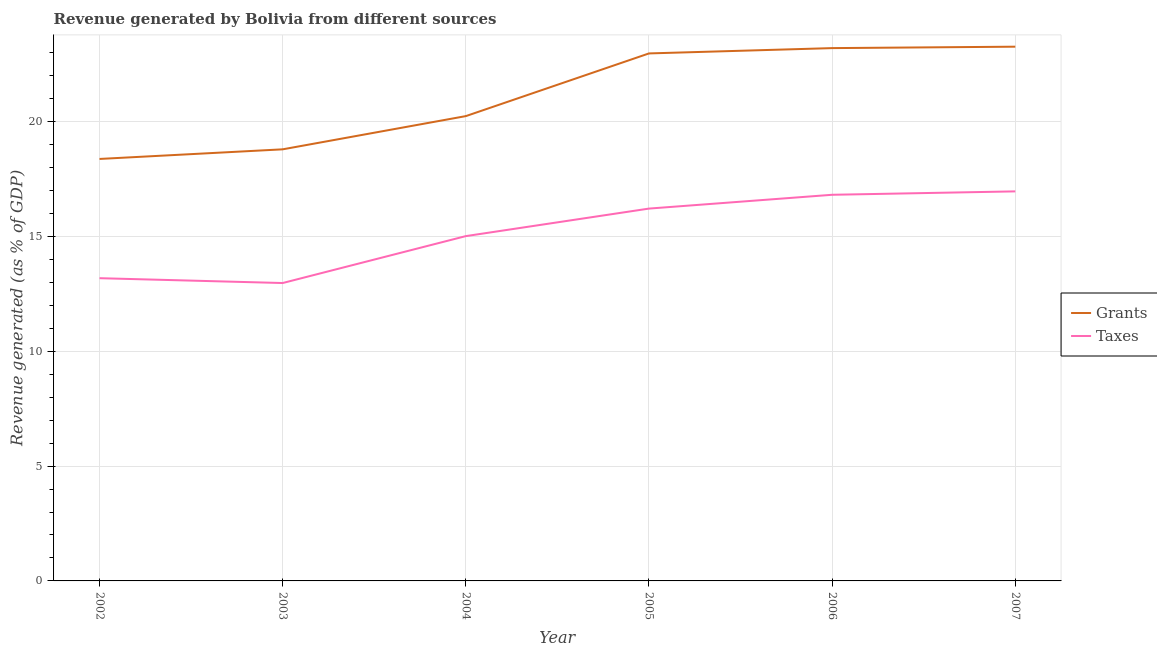How many different coloured lines are there?
Ensure brevity in your answer.  2. What is the revenue generated by grants in 2003?
Ensure brevity in your answer.  18.8. Across all years, what is the maximum revenue generated by taxes?
Provide a succinct answer. 16.96. Across all years, what is the minimum revenue generated by taxes?
Offer a terse response. 12.97. In which year was the revenue generated by taxes maximum?
Provide a short and direct response. 2007. In which year was the revenue generated by grants minimum?
Your response must be concise. 2002. What is the total revenue generated by taxes in the graph?
Make the answer very short. 91.17. What is the difference between the revenue generated by grants in 2005 and that in 2007?
Give a very brief answer. -0.29. What is the difference between the revenue generated by taxes in 2002 and the revenue generated by grants in 2005?
Keep it short and to the point. -9.79. What is the average revenue generated by taxes per year?
Ensure brevity in your answer.  15.19. In the year 2002, what is the difference between the revenue generated by taxes and revenue generated by grants?
Ensure brevity in your answer.  -5.19. In how many years, is the revenue generated by grants greater than 15 %?
Offer a very short reply. 6. What is the ratio of the revenue generated by taxes in 2005 to that in 2006?
Provide a succinct answer. 0.96. Is the revenue generated by taxes in 2004 less than that in 2005?
Give a very brief answer. Yes. Is the difference between the revenue generated by grants in 2002 and 2005 greater than the difference between the revenue generated by taxes in 2002 and 2005?
Provide a short and direct response. No. What is the difference between the highest and the second highest revenue generated by taxes?
Your answer should be compact. 0.15. What is the difference between the highest and the lowest revenue generated by taxes?
Keep it short and to the point. 3.99. Is the sum of the revenue generated by grants in 2002 and 2005 greater than the maximum revenue generated by taxes across all years?
Your answer should be very brief. Yes. Does the revenue generated by taxes monotonically increase over the years?
Provide a succinct answer. No. How many lines are there?
Offer a terse response. 2. How many years are there in the graph?
Offer a very short reply. 6. Are the values on the major ticks of Y-axis written in scientific E-notation?
Your answer should be very brief. No. Does the graph contain any zero values?
Provide a succinct answer. No. How many legend labels are there?
Ensure brevity in your answer.  2. What is the title of the graph?
Provide a short and direct response. Revenue generated by Bolivia from different sources. What is the label or title of the Y-axis?
Your answer should be very brief. Revenue generated (as % of GDP). What is the Revenue generated (as % of GDP) in Grants in 2002?
Your response must be concise. 18.38. What is the Revenue generated (as % of GDP) of Taxes in 2002?
Give a very brief answer. 13.18. What is the Revenue generated (as % of GDP) of Grants in 2003?
Offer a terse response. 18.8. What is the Revenue generated (as % of GDP) in Taxes in 2003?
Offer a terse response. 12.97. What is the Revenue generated (as % of GDP) in Grants in 2004?
Your response must be concise. 20.24. What is the Revenue generated (as % of GDP) of Taxes in 2004?
Ensure brevity in your answer.  15.02. What is the Revenue generated (as % of GDP) of Grants in 2005?
Offer a very short reply. 22.97. What is the Revenue generated (as % of GDP) of Taxes in 2005?
Offer a very short reply. 16.22. What is the Revenue generated (as % of GDP) in Grants in 2006?
Provide a short and direct response. 23.2. What is the Revenue generated (as % of GDP) in Taxes in 2006?
Offer a very short reply. 16.82. What is the Revenue generated (as % of GDP) of Grants in 2007?
Your answer should be compact. 23.27. What is the Revenue generated (as % of GDP) in Taxes in 2007?
Your answer should be compact. 16.96. Across all years, what is the maximum Revenue generated (as % of GDP) in Grants?
Your answer should be compact. 23.27. Across all years, what is the maximum Revenue generated (as % of GDP) in Taxes?
Give a very brief answer. 16.96. Across all years, what is the minimum Revenue generated (as % of GDP) in Grants?
Keep it short and to the point. 18.38. Across all years, what is the minimum Revenue generated (as % of GDP) of Taxes?
Make the answer very short. 12.97. What is the total Revenue generated (as % of GDP) of Grants in the graph?
Give a very brief answer. 126.86. What is the total Revenue generated (as % of GDP) in Taxes in the graph?
Keep it short and to the point. 91.17. What is the difference between the Revenue generated (as % of GDP) in Grants in 2002 and that in 2003?
Offer a very short reply. -0.42. What is the difference between the Revenue generated (as % of GDP) in Taxes in 2002 and that in 2003?
Ensure brevity in your answer.  0.21. What is the difference between the Revenue generated (as % of GDP) in Grants in 2002 and that in 2004?
Provide a short and direct response. -1.87. What is the difference between the Revenue generated (as % of GDP) of Taxes in 2002 and that in 2004?
Offer a very short reply. -1.83. What is the difference between the Revenue generated (as % of GDP) of Grants in 2002 and that in 2005?
Make the answer very short. -4.6. What is the difference between the Revenue generated (as % of GDP) in Taxes in 2002 and that in 2005?
Provide a succinct answer. -3.03. What is the difference between the Revenue generated (as % of GDP) in Grants in 2002 and that in 2006?
Your response must be concise. -4.83. What is the difference between the Revenue generated (as % of GDP) of Taxes in 2002 and that in 2006?
Make the answer very short. -3.63. What is the difference between the Revenue generated (as % of GDP) in Grants in 2002 and that in 2007?
Ensure brevity in your answer.  -4.89. What is the difference between the Revenue generated (as % of GDP) in Taxes in 2002 and that in 2007?
Your answer should be compact. -3.78. What is the difference between the Revenue generated (as % of GDP) of Grants in 2003 and that in 2004?
Your answer should be compact. -1.45. What is the difference between the Revenue generated (as % of GDP) of Taxes in 2003 and that in 2004?
Give a very brief answer. -2.04. What is the difference between the Revenue generated (as % of GDP) in Grants in 2003 and that in 2005?
Offer a very short reply. -4.18. What is the difference between the Revenue generated (as % of GDP) of Taxes in 2003 and that in 2005?
Your answer should be very brief. -3.24. What is the difference between the Revenue generated (as % of GDP) of Grants in 2003 and that in 2006?
Ensure brevity in your answer.  -4.41. What is the difference between the Revenue generated (as % of GDP) of Taxes in 2003 and that in 2006?
Ensure brevity in your answer.  -3.84. What is the difference between the Revenue generated (as % of GDP) in Grants in 2003 and that in 2007?
Offer a terse response. -4.47. What is the difference between the Revenue generated (as % of GDP) of Taxes in 2003 and that in 2007?
Your response must be concise. -3.99. What is the difference between the Revenue generated (as % of GDP) of Grants in 2004 and that in 2005?
Your answer should be compact. -2.73. What is the difference between the Revenue generated (as % of GDP) of Taxes in 2004 and that in 2005?
Your answer should be compact. -1.2. What is the difference between the Revenue generated (as % of GDP) in Grants in 2004 and that in 2006?
Make the answer very short. -2.96. What is the difference between the Revenue generated (as % of GDP) in Taxes in 2004 and that in 2006?
Offer a terse response. -1.8. What is the difference between the Revenue generated (as % of GDP) of Grants in 2004 and that in 2007?
Your response must be concise. -3.02. What is the difference between the Revenue generated (as % of GDP) in Taxes in 2004 and that in 2007?
Provide a short and direct response. -1.95. What is the difference between the Revenue generated (as % of GDP) of Grants in 2005 and that in 2006?
Your response must be concise. -0.23. What is the difference between the Revenue generated (as % of GDP) of Taxes in 2005 and that in 2006?
Offer a very short reply. -0.6. What is the difference between the Revenue generated (as % of GDP) of Grants in 2005 and that in 2007?
Offer a very short reply. -0.29. What is the difference between the Revenue generated (as % of GDP) of Taxes in 2005 and that in 2007?
Give a very brief answer. -0.75. What is the difference between the Revenue generated (as % of GDP) of Grants in 2006 and that in 2007?
Provide a short and direct response. -0.06. What is the difference between the Revenue generated (as % of GDP) of Taxes in 2006 and that in 2007?
Offer a terse response. -0.15. What is the difference between the Revenue generated (as % of GDP) in Grants in 2002 and the Revenue generated (as % of GDP) in Taxes in 2003?
Your answer should be very brief. 5.4. What is the difference between the Revenue generated (as % of GDP) in Grants in 2002 and the Revenue generated (as % of GDP) in Taxes in 2004?
Your answer should be very brief. 3.36. What is the difference between the Revenue generated (as % of GDP) of Grants in 2002 and the Revenue generated (as % of GDP) of Taxes in 2005?
Your answer should be very brief. 2.16. What is the difference between the Revenue generated (as % of GDP) in Grants in 2002 and the Revenue generated (as % of GDP) in Taxes in 2006?
Your answer should be compact. 1.56. What is the difference between the Revenue generated (as % of GDP) of Grants in 2002 and the Revenue generated (as % of GDP) of Taxes in 2007?
Your answer should be compact. 1.41. What is the difference between the Revenue generated (as % of GDP) of Grants in 2003 and the Revenue generated (as % of GDP) of Taxes in 2004?
Make the answer very short. 3.78. What is the difference between the Revenue generated (as % of GDP) of Grants in 2003 and the Revenue generated (as % of GDP) of Taxes in 2005?
Your answer should be very brief. 2.58. What is the difference between the Revenue generated (as % of GDP) in Grants in 2003 and the Revenue generated (as % of GDP) in Taxes in 2006?
Give a very brief answer. 1.98. What is the difference between the Revenue generated (as % of GDP) of Grants in 2003 and the Revenue generated (as % of GDP) of Taxes in 2007?
Ensure brevity in your answer.  1.83. What is the difference between the Revenue generated (as % of GDP) in Grants in 2004 and the Revenue generated (as % of GDP) in Taxes in 2005?
Your answer should be very brief. 4.03. What is the difference between the Revenue generated (as % of GDP) in Grants in 2004 and the Revenue generated (as % of GDP) in Taxes in 2006?
Keep it short and to the point. 3.43. What is the difference between the Revenue generated (as % of GDP) in Grants in 2004 and the Revenue generated (as % of GDP) in Taxes in 2007?
Offer a terse response. 3.28. What is the difference between the Revenue generated (as % of GDP) of Grants in 2005 and the Revenue generated (as % of GDP) of Taxes in 2006?
Provide a short and direct response. 6.16. What is the difference between the Revenue generated (as % of GDP) of Grants in 2005 and the Revenue generated (as % of GDP) of Taxes in 2007?
Offer a very short reply. 6.01. What is the difference between the Revenue generated (as % of GDP) of Grants in 2006 and the Revenue generated (as % of GDP) of Taxes in 2007?
Provide a short and direct response. 6.24. What is the average Revenue generated (as % of GDP) in Grants per year?
Keep it short and to the point. 21.14. What is the average Revenue generated (as % of GDP) in Taxes per year?
Keep it short and to the point. 15.19. In the year 2002, what is the difference between the Revenue generated (as % of GDP) of Grants and Revenue generated (as % of GDP) of Taxes?
Your answer should be compact. 5.19. In the year 2003, what is the difference between the Revenue generated (as % of GDP) in Grants and Revenue generated (as % of GDP) in Taxes?
Your answer should be very brief. 5.82. In the year 2004, what is the difference between the Revenue generated (as % of GDP) in Grants and Revenue generated (as % of GDP) in Taxes?
Your answer should be compact. 5.23. In the year 2005, what is the difference between the Revenue generated (as % of GDP) of Grants and Revenue generated (as % of GDP) of Taxes?
Provide a short and direct response. 6.76. In the year 2006, what is the difference between the Revenue generated (as % of GDP) of Grants and Revenue generated (as % of GDP) of Taxes?
Provide a short and direct response. 6.39. In the year 2007, what is the difference between the Revenue generated (as % of GDP) in Grants and Revenue generated (as % of GDP) in Taxes?
Make the answer very short. 6.3. What is the ratio of the Revenue generated (as % of GDP) of Grants in 2002 to that in 2003?
Make the answer very short. 0.98. What is the ratio of the Revenue generated (as % of GDP) in Taxes in 2002 to that in 2003?
Your answer should be compact. 1.02. What is the ratio of the Revenue generated (as % of GDP) of Grants in 2002 to that in 2004?
Your answer should be compact. 0.91. What is the ratio of the Revenue generated (as % of GDP) in Taxes in 2002 to that in 2004?
Your answer should be very brief. 0.88. What is the ratio of the Revenue generated (as % of GDP) of Taxes in 2002 to that in 2005?
Keep it short and to the point. 0.81. What is the ratio of the Revenue generated (as % of GDP) in Grants in 2002 to that in 2006?
Your answer should be very brief. 0.79. What is the ratio of the Revenue generated (as % of GDP) of Taxes in 2002 to that in 2006?
Your answer should be very brief. 0.78. What is the ratio of the Revenue generated (as % of GDP) in Grants in 2002 to that in 2007?
Provide a short and direct response. 0.79. What is the ratio of the Revenue generated (as % of GDP) of Taxes in 2002 to that in 2007?
Provide a succinct answer. 0.78. What is the ratio of the Revenue generated (as % of GDP) of Grants in 2003 to that in 2004?
Give a very brief answer. 0.93. What is the ratio of the Revenue generated (as % of GDP) of Taxes in 2003 to that in 2004?
Ensure brevity in your answer.  0.86. What is the ratio of the Revenue generated (as % of GDP) in Grants in 2003 to that in 2005?
Keep it short and to the point. 0.82. What is the ratio of the Revenue generated (as % of GDP) of Taxes in 2003 to that in 2005?
Keep it short and to the point. 0.8. What is the ratio of the Revenue generated (as % of GDP) in Grants in 2003 to that in 2006?
Ensure brevity in your answer.  0.81. What is the ratio of the Revenue generated (as % of GDP) of Taxes in 2003 to that in 2006?
Keep it short and to the point. 0.77. What is the ratio of the Revenue generated (as % of GDP) in Grants in 2003 to that in 2007?
Your response must be concise. 0.81. What is the ratio of the Revenue generated (as % of GDP) of Taxes in 2003 to that in 2007?
Provide a succinct answer. 0.76. What is the ratio of the Revenue generated (as % of GDP) in Grants in 2004 to that in 2005?
Keep it short and to the point. 0.88. What is the ratio of the Revenue generated (as % of GDP) of Taxes in 2004 to that in 2005?
Provide a short and direct response. 0.93. What is the ratio of the Revenue generated (as % of GDP) of Grants in 2004 to that in 2006?
Offer a very short reply. 0.87. What is the ratio of the Revenue generated (as % of GDP) of Taxes in 2004 to that in 2006?
Ensure brevity in your answer.  0.89. What is the ratio of the Revenue generated (as % of GDP) of Grants in 2004 to that in 2007?
Keep it short and to the point. 0.87. What is the ratio of the Revenue generated (as % of GDP) in Taxes in 2004 to that in 2007?
Provide a succinct answer. 0.89. What is the ratio of the Revenue generated (as % of GDP) of Grants in 2005 to that in 2006?
Keep it short and to the point. 0.99. What is the ratio of the Revenue generated (as % of GDP) of Grants in 2005 to that in 2007?
Your response must be concise. 0.99. What is the ratio of the Revenue generated (as % of GDP) in Taxes in 2005 to that in 2007?
Provide a succinct answer. 0.96. What is the ratio of the Revenue generated (as % of GDP) of Grants in 2006 to that in 2007?
Provide a succinct answer. 1. What is the difference between the highest and the second highest Revenue generated (as % of GDP) of Grants?
Keep it short and to the point. 0.06. What is the difference between the highest and the second highest Revenue generated (as % of GDP) of Taxes?
Your response must be concise. 0.15. What is the difference between the highest and the lowest Revenue generated (as % of GDP) in Grants?
Make the answer very short. 4.89. What is the difference between the highest and the lowest Revenue generated (as % of GDP) of Taxes?
Keep it short and to the point. 3.99. 